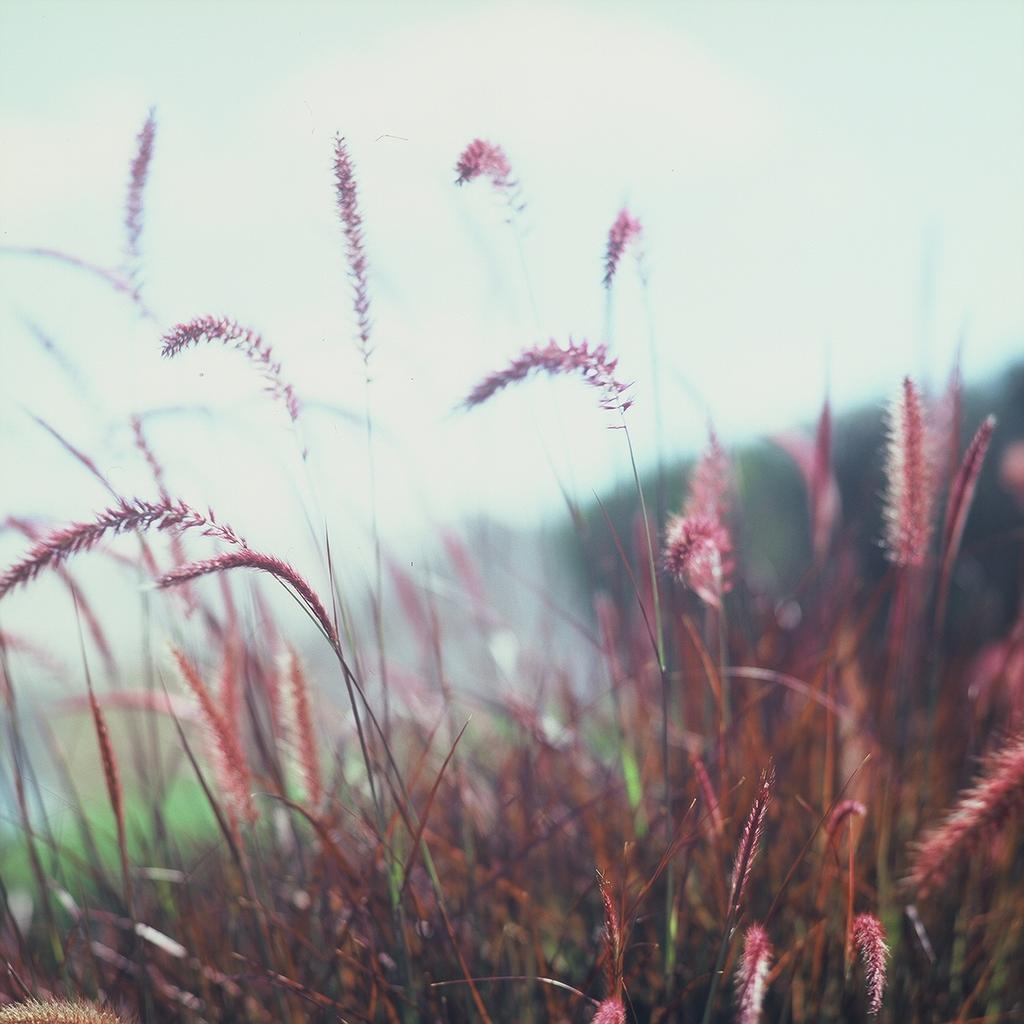What color is the grass in the image? The grass in the image is maroon in color. What can be seen in the background of the image? There are trees and the sky visible in the background of the image. What type of cord is being used to tie the tail of the animal in the image? There is no animal or cord present in the image; it features maroon grass and trees in the background. 